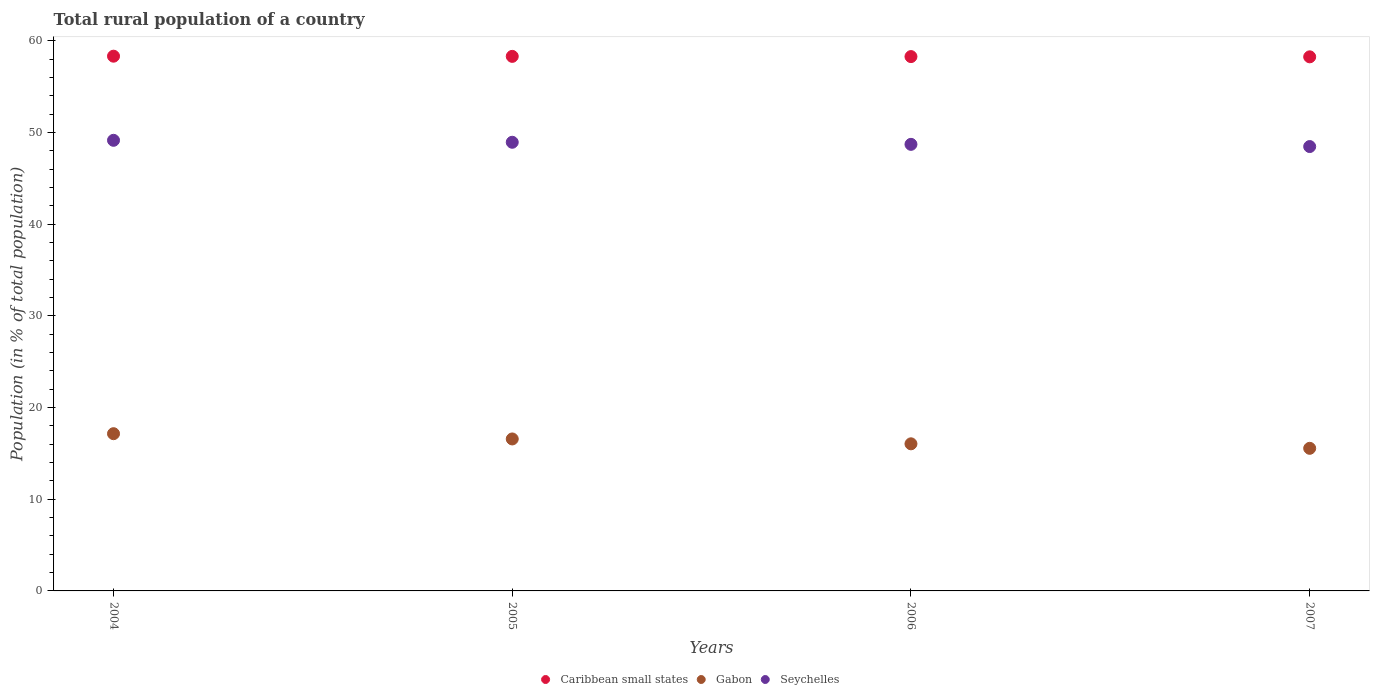How many different coloured dotlines are there?
Give a very brief answer. 3. What is the rural population in Caribbean small states in 2006?
Ensure brevity in your answer.  58.29. Across all years, what is the maximum rural population in Caribbean small states?
Your answer should be compact. 58.34. Across all years, what is the minimum rural population in Caribbean small states?
Give a very brief answer. 58.27. What is the total rural population in Seychelles in the graph?
Ensure brevity in your answer.  195.3. What is the difference between the rural population in Seychelles in 2006 and that in 2007?
Make the answer very short. 0.24. What is the difference between the rural population in Gabon in 2005 and the rural population in Caribbean small states in 2007?
Make the answer very short. -41.69. What is the average rural population in Gabon per year?
Your response must be concise. 16.33. In the year 2007, what is the difference between the rural population in Gabon and rural population in Seychelles?
Provide a short and direct response. -32.92. What is the ratio of the rural population in Caribbean small states in 2004 to that in 2005?
Keep it short and to the point. 1. Is the rural population in Seychelles in 2004 less than that in 2005?
Your response must be concise. No. What is the difference between the highest and the second highest rural population in Seychelles?
Give a very brief answer. 0.21. What is the difference between the highest and the lowest rural population in Seychelles?
Keep it short and to the point. 0.68. How many dotlines are there?
Offer a very short reply. 3. How many years are there in the graph?
Offer a terse response. 4. What is the difference between two consecutive major ticks on the Y-axis?
Ensure brevity in your answer.  10. Are the values on the major ticks of Y-axis written in scientific E-notation?
Offer a terse response. No. Does the graph contain grids?
Provide a succinct answer. No. Where does the legend appear in the graph?
Your response must be concise. Bottom center. What is the title of the graph?
Make the answer very short. Total rural population of a country. Does "Bhutan" appear as one of the legend labels in the graph?
Provide a succinct answer. No. What is the label or title of the X-axis?
Ensure brevity in your answer.  Years. What is the label or title of the Y-axis?
Your answer should be very brief. Population (in % of total population). What is the Population (in % of total population) in Caribbean small states in 2004?
Ensure brevity in your answer.  58.34. What is the Population (in % of total population) in Gabon in 2004?
Your answer should be very brief. 17.15. What is the Population (in % of total population) of Seychelles in 2004?
Provide a succinct answer. 49.16. What is the Population (in % of total population) in Caribbean small states in 2005?
Offer a very short reply. 58.32. What is the Population (in % of total population) of Gabon in 2005?
Ensure brevity in your answer.  16.58. What is the Population (in % of total population) of Seychelles in 2005?
Provide a succinct answer. 48.95. What is the Population (in % of total population) in Caribbean small states in 2006?
Keep it short and to the point. 58.29. What is the Population (in % of total population) in Gabon in 2006?
Make the answer very short. 16.05. What is the Population (in % of total population) of Seychelles in 2006?
Make the answer very short. 48.72. What is the Population (in % of total population) of Caribbean small states in 2007?
Make the answer very short. 58.27. What is the Population (in % of total population) in Gabon in 2007?
Offer a very short reply. 15.56. What is the Population (in % of total population) in Seychelles in 2007?
Your answer should be very brief. 48.48. Across all years, what is the maximum Population (in % of total population) in Caribbean small states?
Your answer should be very brief. 58.34. Across all years, what is the maximum Population (in % of total population) of Gabon?
Give a very brief answer. 17.15. Across all years, what is the maximum Population (in % of total population) of Seychelles?
Your answer should be very brief. 49.16. Across all years, what is the minimum Population (in % of total population) of Caribbean small states?
Make the answer very short. 58.27. Across all years, what is the minimum Population (in % of total population) of Gabon?
Your response must be concise. 15.56. Across all years, what is the minimum Population (in % of total population) of Seychelles?
Offer a terse response. 48.48. What is the total Population (in % of total population) of Caribbean small states in the graph?
Ensure brevity in your answer.  233.21. What is the total Population (in % of total population) in Gabon in the graph?
Offer a terse response. 65.34. What is the total Population (in % of total population) of Seychelles in the graph?
Give a very brief answer. 195.3. What is the difference between the Population (in % of total population) in Caribbean small states in 2004 and that in 2005?
Offer a very short reply. 0.02. What is the difference between the Population (in % of total population) in Gabon in 2004 and that in 2005?
Make the answer very short. 0.57. What is the difference between the Population (in % of total population) in Seychelles in 2004 and that in 2005?
Keep it short and to the point. 0.21. What is the difference between the Population (in % of total population) of Caribbean small states in 2004 and that in 2006?
Provide a short and direct response. 0.04. What is the difference between the Population (in % of total population) of Gabon in 2004 and that in 2006?
Make the answer very short. 1.1. What is the difference between the Population (in % of total population) of Seychelles in 2004 and that in 2006?
Offer a terse response. 0.44. What is the difference between the Population (in % of total population) of Caribbean small states in 2004 and that in 2007?
Give a very brief answer. 0.07. What is the difference between the Population (in % of total population) in Gabon in 2004 and that in 2007?
Offer a very short reply. 1.6. What is the difference between the Population (in % of total population) in Seychelles in 2004 and that in 2007?
Offer a very short reply. 0.68. What is the difference between the Population (in % of total population) in Caribbean small states in 2005 and that in 2006?
Provide a succinct answer. 0.02. What is the difference between the Population (in % of total population) in Gabon in 2005 and that in 2006?
Give a very brief answer. 0.53. What is the difference between the Population (in % of total population) in Seychelles in 2005 and that in 2006?
Ensure brevity in your answer.  0.23. What is the difference between the Population (in % of total population) in Caribbean small states in 2005 and that in 2007?
Keep it short and to the point. 0.05. What is the difference between the Population (in % of total population) in Gabon in 2005 and that in 2007?
Your answer should be very brief. 1.02. What is the difference between the Population (in % of total population) of Seychelles in 2005 and that in 2007?
Provide a short and direct response. 0.47. What is the difference between the Population (in % of total population) of Caribbean small states in 2006 and that in 2007?
Provide a succinct answer. 0.03. What is the difference between the Population (in % of total population) in Gabon in 2006 and that in 2007?
Ensure brevity in your answer.  0.49. What is the difference between the Population (in % of total population) in Seychelles in 2006 and that in 2007?
Provide a short and direct response. 0.24. What is the difference between the Population (in % of total population) in Caribbean small states in 2004 and the Population (in % of total population) in Gabon in 2005?
Offer a very short reply. 41.76. What is the difference between the Population (in % of total population) in Caribbean small states in 2004 and the Population (in % of total population) in Seychelles in 2005?
Offer a very short reply. 9.39. What is the difference between the Population (in % of total population) in Gabon in 2004 and the Population (in % of total population) in Seychelles in 2005?
Provide a succinct answer. -31.79. What is the difference between the Population (in % of total population) of Caribbean small states in 2004 and the Population (in % of total population) of Gabon in 2006?
Make the answer very short. 42.29. What is the difference between the Population (in % of total population) in Caribbean small states in 2004 and the Population (in % of total population) in Seychelles in 2006?
Ensure brevity in your answer.  9.62. What is the difference between the Population (in % of total population) of Gabon in 2004 and the Population (in % of total population) of Seychelles in 2006?
Offer a very short reply. -31.57. What is the difference between the Population (in % of total population) in Caribbean small states in 2004 and the Population (in % of total population) in Gabon in 2007?
Offer a terse response. 42.78. What is the difference between the Population (in % of total population) in Caribbean small states in 2004 and the Population (in % of total population) in Seychelles in 2007?
Ensure brevity in your answer.  9.86. What is the difference between the Population (in % of total population) of Gabon in 2004 and the Population (in % of total population) of Seychelles in 2007?
Keep it short and to the point. -31.32. What is the difference between the Population (in % of total population) in Caribbean small states in 2005 and the Population (in % of total population) in Gabon in 2006?
Offer a terse response. 42.27. What is the difference between the Population (in % of total population) in Caribbean small states in 2005 and the Population (in % of total population) in Seychelles in 2006?
Keep it short and to the point. 9.6. What is the difference between the Population (in % of total population) of Gabon in 2005 and the Population (in % of total population) of Seychelles in 2006?
Provide a short and direct response. -32.14. What is the difference between the Population (in % of total population) in Caribbean small states in 2005 and the Population (in % of total population) in Gabon in 2007?
Offer a very short reply. 42.76. What is the difference between the Population (in % of total population) of Caribbean small states in 2005 and the Population (in % of total population) of Seychelles in 2007?
Provide a succinct answer. 9.84. What is the difference between the Population (in % of total population) of Gabon in 2005 and the Population (in % of total population) of Seychelles in 2007?
Your answer should be very brief. -31.9. What is the difference between the Population (in % of total population) of Caribbean small states in 2006 and the Population (in % of total population) of Gabon in 2007?
Your response must be concise. 42.73. What is the difference between the Population (in % of total population) in Caribbean small states in 2006 and the Population (in % of total population) in Seychelles in 2007?
Ensure brevity in your answer.  9.81. What is the difference between the Population (in % of total population) in Gabon in 2006 and the Population (in % of total population) in Seychelles in 2007?
Give a very brief answer. -32.43. What is the average Population (in % of total population) in Caribbean small states per year?
Provide a succinct answer. 58.3. What is the average Population (in % of total population) in Gabon per year?
Offer a very short reply. 16.33. What is the average Population (in % of total population) in Seychelles per year?
Provide a short and direct response. 48.83. In the year 2004, what is the difference between the Population (in % of total population) of Caribbean small states and Population (in % of total population) of Gabon?
Offer a terse response. 41.18. In the year 2004, what is the difference between the Population (in % of total population) in Caribbean small states and Population (in % of total population) in Seychelles?
Offer a very short reply. 9.18. In the year 2004, what is the difference between the Population (in % of total population) of Gabon and Population (in % of total population) of Seychelles?
Provide a short and direct response. -32.01. In the year 2005, what is the difference between the Population (in % of total population) in Caribbean small states and Population (in % of total population) in Gabon?
Offer a very short reply. 41.74. In the year 2005, what is the difference between the Population (in % of total population) in Caribbean small states and Population (in % of total population) in Seychelles?
Give a very brief answer. 9.37. In the year 2005, what is the difference between the Population (in % of total population) of Gabon and Population (in % of total population) of Seychelles?
Your response must be concise. -32.37. In the year 2006, what is the difference between the Population (in % of total population) of Caribbean small states and Population (in % of total population) of Gabon?
Provide a succinct answer. 42.24. In the year 2006, what is the difference between the Population (in % of total population) of Caribbean small states and Population (in % of total population) of Seychelles?
Your answer should be very brief. 9.57. In the year 2006, what is the difference between the Population (in % of total population) of Gabon and Population (in % of total population) of Seychelles?
Your answer should be very brief. -32.67. In the year 2007, what is the difference between the Population (in % of total population) in Caribbean small states and Population (in % of total population) in Gabon?
Offer a very short reply. 42.71. In the year 2007, what is the difference between the Population (in % of total population) in Caribbean small states and Population (in % of total population) in Seychelles?
Your answer should be very brief. 9.79. In the year 2007, what is the difference between the Population (in % of total population) in Gabon and Population (in % of total population) in Seychelles?
Provide a short and direct response. -32.92. What is the ratio of the Population (in % of total population) in Caribbean small states in 2004 to that in 2005?
Give a very brief answer. 1. What is the ratio of the Population (in % of total population) in Gabon in 2004 to that in 2005?
Give a very brief answer. 1.03. What is the ratio of the Population (in % of total population) in Caribbean small states in 2004 to that in 2006?
Ensure brevity in your answer.  1. What is the ratio of the Population (in % of total population) of Gabon in 2004 to that in 2006?
Give a very brief answer. 1.07. What is the ratio of the Population (in % of total population) in Seychelles in 2004 to that in 2006?
Provide a short and direct response. 1.01. What is the ratio of the Population (in % of total population) of Gabon in 2004 to that in 2007?
Offer a very short reply. 1.1. What is the ratio of the Population (in % of total population) in Seychelles in 2004 to that in 2007?
Offer a terse response. 1.01. What is the ratio of the Population (in % of total population) in Caribbean small states in 2005 to that in 2006?
Keep it short and to the point. 1. What is the ratio of the Population (in % of total population) in Gabon in 2005 to that in 2006?
Offer a very short reply. 1.03. What is the ratio of the Population (in % of total population) of Seychelles in 2005 to that in 2006?
Give a very brief answer. 1. What is the ratio of the Population (in % of total population) of Gabon in 2005 to that in 2007?
Your answer should be very brief. 1.07. What is the ratio of the Population (in % of total population) of Seychelles in 2005 to that in 2007?
Offer a terse response. 1.01. What is the ratio of the Population (in % of total population) in Gabon in 2006 to that in 2007?
Give a very brief answer. 1.03. What is the ratio of the Population (in % of total population) in Seychelles in 2006 to that in 2007?
Your response must be concise. 1. What is the difference between the highest and the second highest Population (in % of total population) of Caribbean small states?
Your answer should be compact. 0.02. What is the difference between the highest and the second highest Population (in % of total population) of Gabon?
Give a very brief answer. 0.57. What is the difference between the highest and the second highest Population (in % of total population) in Seychelles?
Your answer should be very brief. 0.21. What is the difference between the highest and the lowest Population (in % of total population) of Caribbean small states?
Your answer should be compact. 0.07. What is the difference between the highest and the lowest Population (in % of total population) in Gabon?
Your answer should be very brief. 1.6. What is the difference between the highest and the lowest Population (in % of total population) in Seychelles?
Keep it short and to the point. 0.68. 